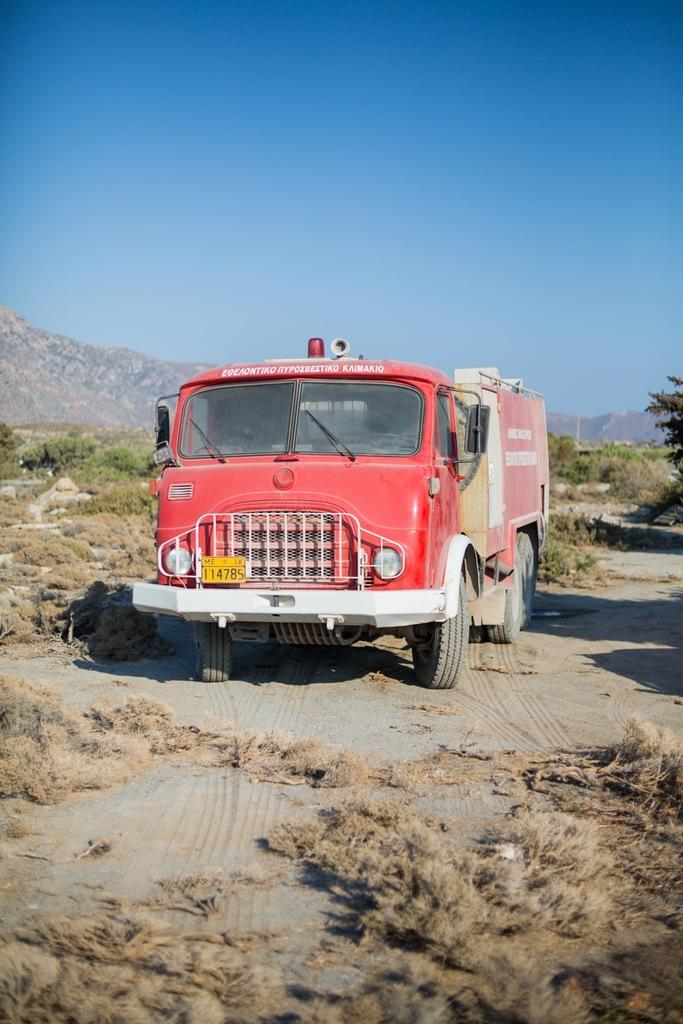What is the main subject in the middle of the image? There is a truck in the middle of the image. What can be seen in the background of the image? There are trees and hills in the background of the image. How does the beginner driver handle the truck in the image? There is no information about the driver's skill level in the image, so we cannot determine if they are a beginner or how they handle the truck. 